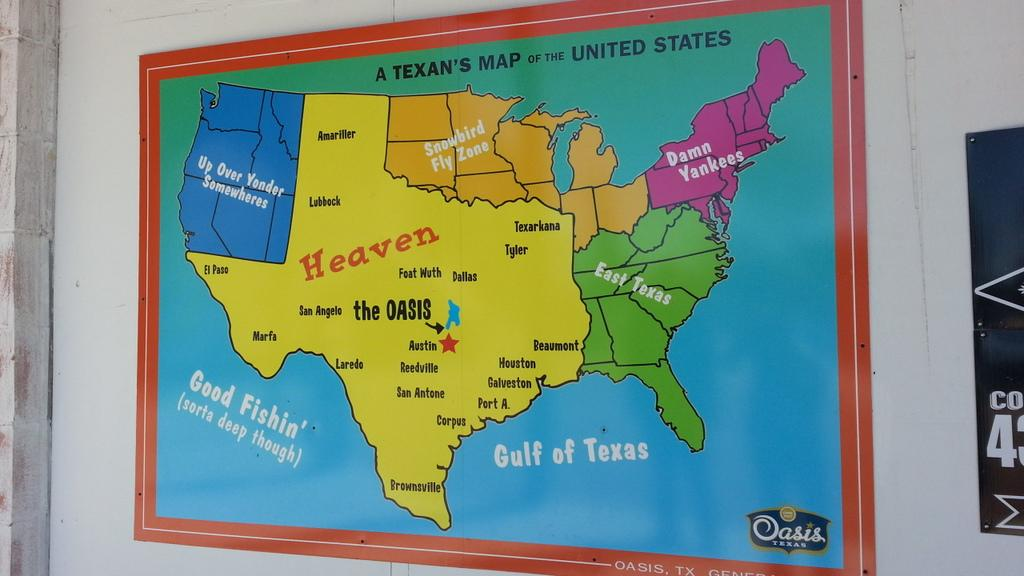<image>
Write a terse but informative summary of the picture. A map of the Unites States shows Texas as heaven. 